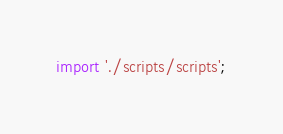Convert code to text. <code><loc_0><loc_0><loc_500><loc_500><_JavaScript_>import './scripts/scripts';
</code> 